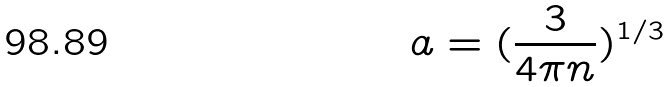<formula> <loc_0><loc_0><loc_500><loc_500>a = ( \frac { 3 } { 4 \pi n } ) ^ { 1 / 3 }</formula> 